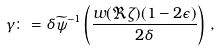<formula> <loc_0><loc_0><loc_500><loc_500>\gamma \colon = \delta \widetilde { \psi } ^ { - 1 } \left ( \frac { w ( \Re \zeta ) ( 1 - 2 \epsilon ) } { 2 \delta } \right ) \, ,</formula> 